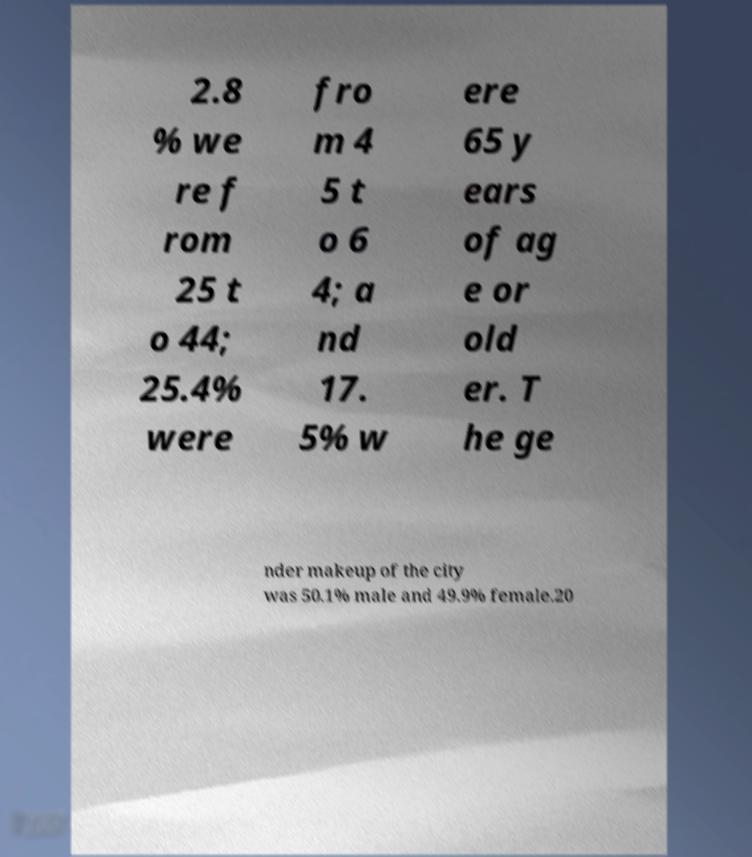Please read and relay the text visible in this image. What does it say? 2.8 % we re f rom 25 t o 44; 25.4% were fro m 4 5 t o 6 4; a nd 17. 5% w ere 65 y ears of ag e or old er. T he ge nder makeup of the city was 50.1% male and 49.9% female.20 